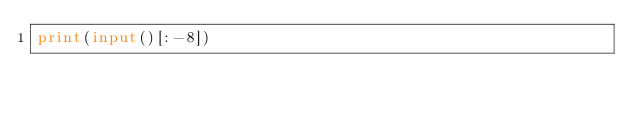Convert code to text. <code><loc_0><loc_0><loc_500><loc_500><_Python_>print(input()[:-8])</code> 